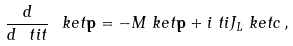Convert formula to latex. <formula><loc_0><loc_0><loc_500><loc_500>\frac { d } { d \ t i { t } } \ k e t { \mathbf p } & = - M \ k e t { \mathbf p } + i \ t i { J _ { L } } \ k e t { c } \, ,</formula> 